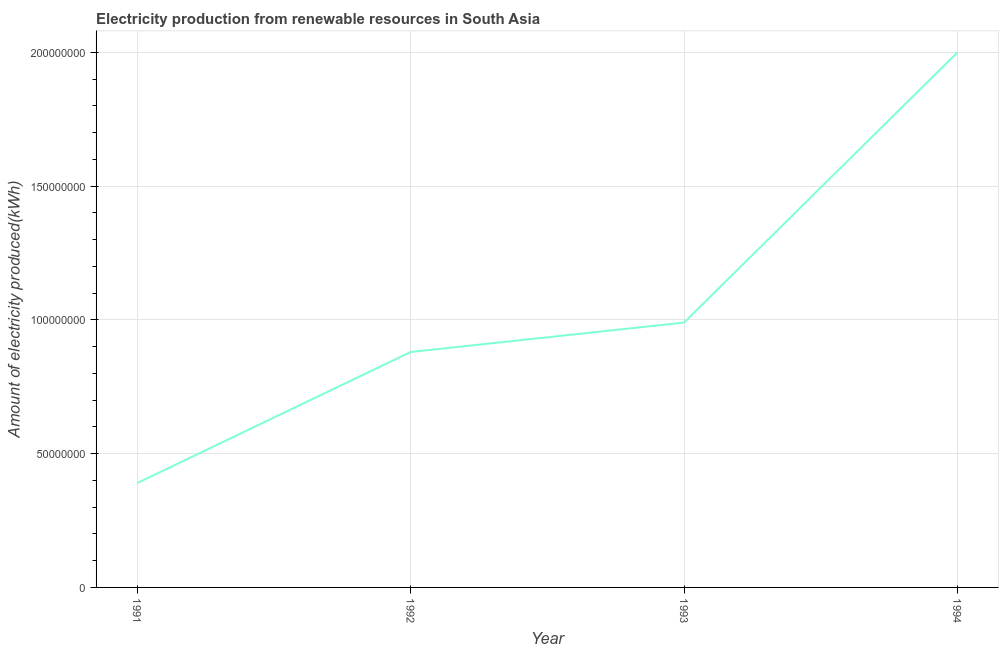What is the amount of electricity produced in 1994?
Ensure brevity in your answer.  2.00e+08. Across all years, what is the maximum amount of electricity produced?
Your response must be concise. 2.00e+08. Across all years, what is the minimum amount of electricity produced?
Ensure brevity in your answer.  3.90e+07. In which year was the amount of electricity produced maximum?
Make the answer very short. 1994. In which year was the amount of electricity produced minimum?
Give a very brief answer. 1991. What is the sum of the amount of electricity produced?
Make the answer very short. 4.26e+08. What is the difference between the amount of electricity produced in 1991 and 1994?
Provide a short and direct response. -1.61e+08. What is the average amount of electricity produced per year?
Offer a very short reply. 1.06e+08. What is the median amount of electricity produced?
Provide a succinct answer. 9.35e+07. Do a majority of the years between 1994 and 1993 (inclusive) have amount of electricity produced greater than 70000000 kWh?
Your response must be concise. No. What is the ratio of the amount of electricity produced in 1992 to that in 1993?
Ensure brevity in your answer.  0.89. Is the difference between the amount of electricity produced in 1992 and 1994 greater than the difference between any two years?
Give a very brief answer. No. What is the difference between the highest and the second highest amount of electricity produced?
Ensure brevity in your answer.  1.01e+08. What is the difference between the highest and the lowest amount of electricity produced?
Offer a terse response. 1.61e+08. In how many years, is the amount of electricity produced greater than the average amount of electricity produced taken over all years?
Provide a short and direct response. 1. How many years are there in the graph?
Your answer should be compact. 4. Are the values on the major ticks of Y-axis written in scientific E-notation?
Your answer should be compact. No. Does the graph contain any zero values?
Offer a very short reply. No. Does the graph contain grids?
Give a very brief answer. Yes. What is the title of the graph?
Ensure brevity in your answer.  Electricity production from renewable resources in South Asia. What is the label or title of the Y-axis?
Your answer should be compact. Amount of electricity produced(kWh). What is the Amount of electricity produced(kWh) of 1991?
Offer a very short reply. 3.90e+07. What is the Amount of electricity produced(kWh) in 1992?
Offer a terse response. 8.80e+07. What is the Amount of electricity produced(kWh) in 1993?
Offer a very short reply. 9.90e+07. What is the Amount of electricity produced(kWh) in 1994?
Provide a short and direct response. 2.00e+08. What is the difference between the Amount of electricity produced(kWh) in 1991 and 1992?
Keep it short and to the point. -4.90e+07. What is the difference between the Amount of electricity produced(kWh) in 1991 and 1993?
Ensure brevity in your answer.  -6.00e+07. What is the difference between the Amount of electricity produced(kWh) in 1991 and 1994?
Make the answer very short. -1.61e+08. What is the difference between the Amount of electricity produced(kWh) in 1992 and 1993?
Ensure brevity in your answer.  -1.10e+07. What is the difference between the Amount of electricity produced(kWh) in 1992 and 1994?
Provide a succinct answer. -1.12e+08. What is the difference between the Amount of electricity produced(kWh) in 1993 and 1994?
Give a very brief answer. -1.01e+08. What is the ratio of the Amount of electricity produced(kWh) in 1991 to that in 1992?
Your response must be concise. 0.44. What is the ratio of the Amount of electricity produced(kWh) in 1991 to that in 1993?
Offer a very short reply. 0.39. What is the ratio of the Amount of electricity produced(kWh) in 1991 to that in 1994?
Your answer should be compact. 0.2. What is the ratio of the Amount of electricity produced(kWh) in 1992 to that in 1993?
Ensure brevity in your answer.  0.89. What is the ratio of the Amount of electricity produced(kWh) in 1992 to that in 1994?
Make the answer very short. 0.44. What is the ratio of the Amount of electricity produced(kWh) in 1993 to that in 1994?
Your response must be concise. 0.49. 